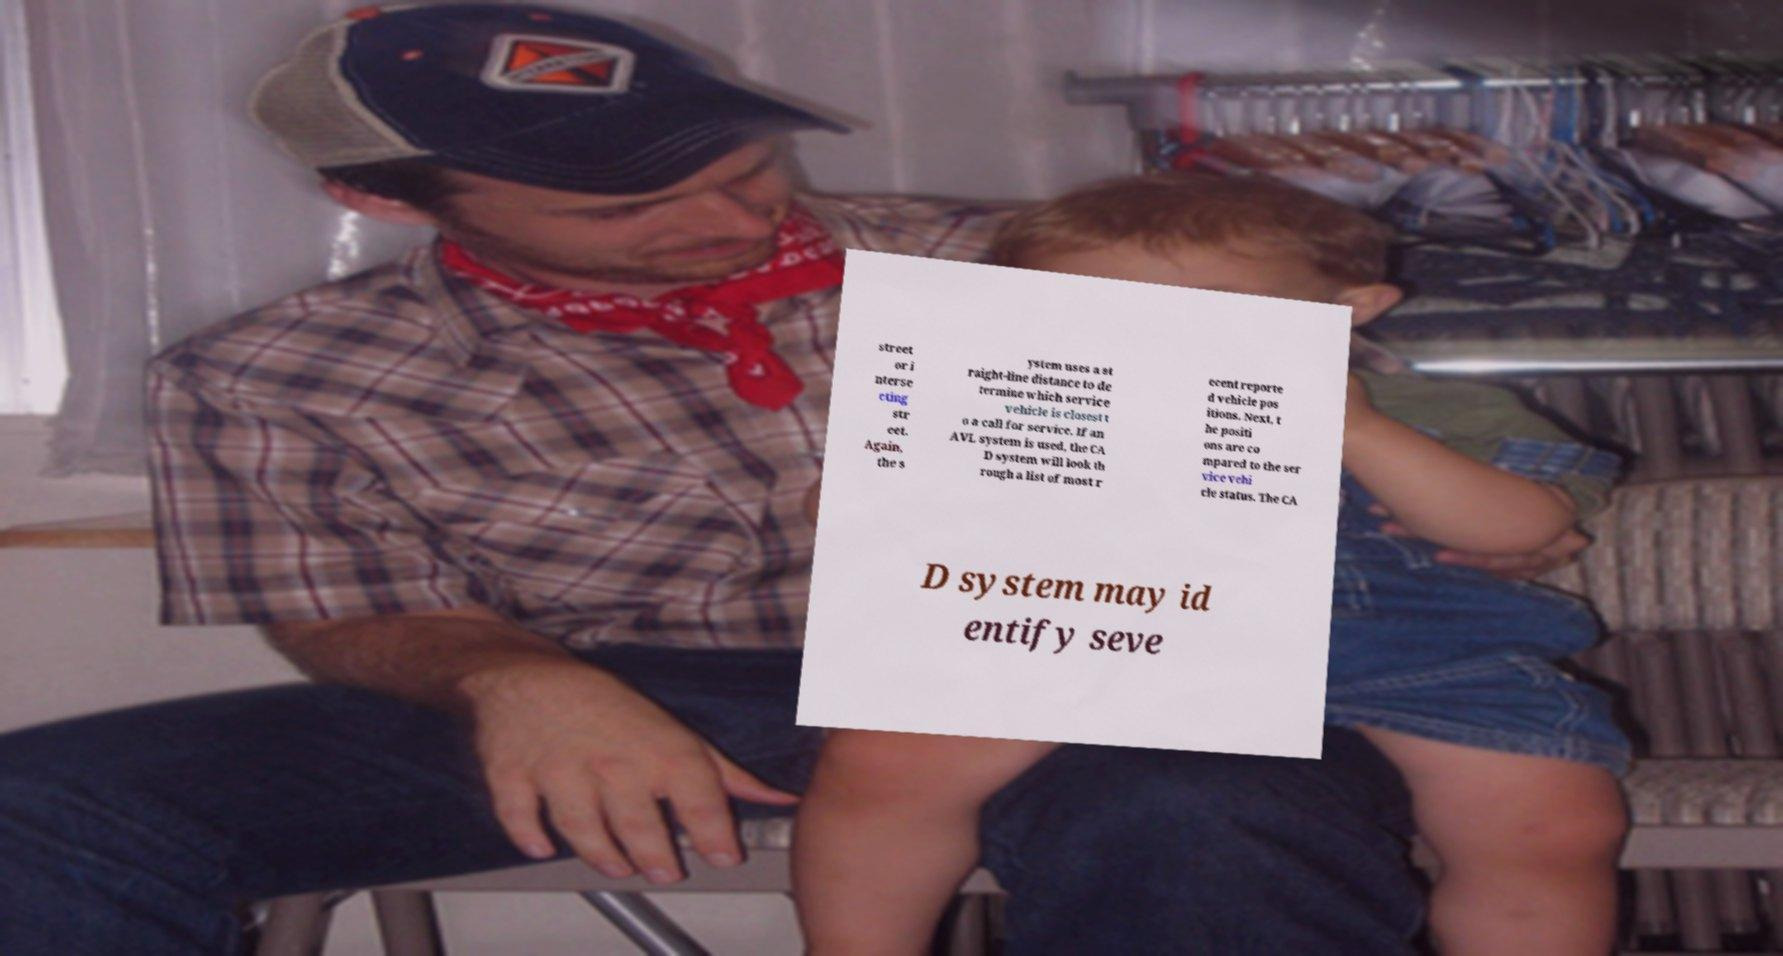For documentation purposes, I need the text within this image transcribed. Could you provide that? street or i nterse cting str eet. Again, the s ystem uses a st raight-line distance to de termine which service vehicle is closest t o a call for service. If an AVL system is used, the CA D system will look th rough a list of most r ecent reporte d vehicle pos itions. Next, t he positi ons are co mpared to the ser vice vehi cle status. The CA D system may id entify seve 